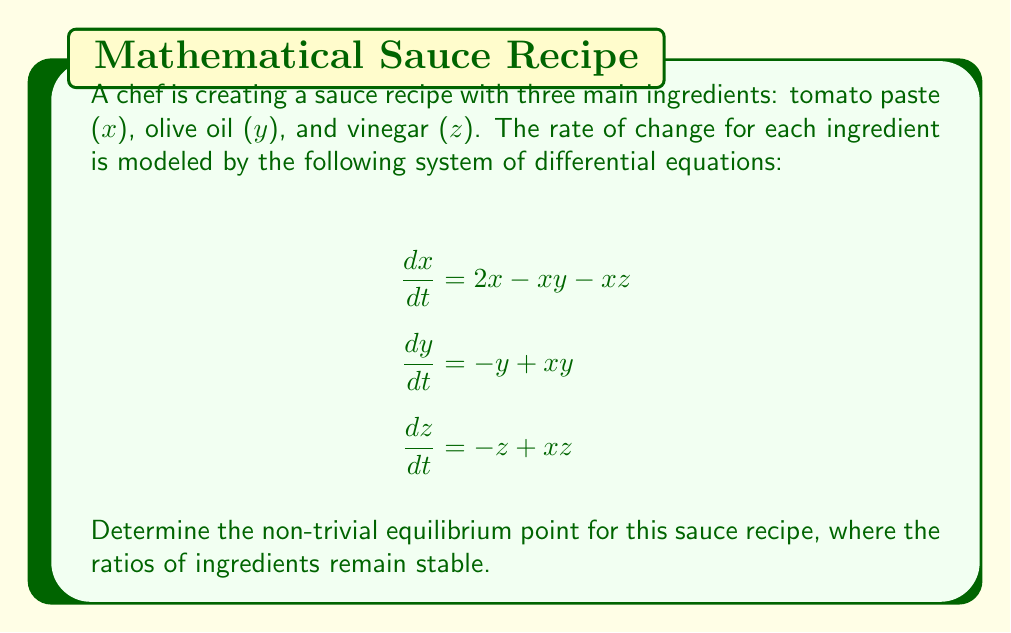Help me with this question. To find the equilibrium point, we need to set all derivatives to zero and solve the resulting system of equations:

1) Set all derivatives to zero:
   $$\begin{align}
   2x - xy - xz &= 0 \\
   -y + xy &= 0 \\
   -z + xz &= 0
   \end{align}$$

2) From the second equation:
   $-y + xy = 0$
   $y(x - 1) = 0$
   So, either $y = 0$ or $x = 1$. Since we're looking for the non-trivial solution, let $x = 1$.

3) From the third equation:
   $-z + xz = 0$
   $-z + 1z = 0$ (since $x = 1$)
   $0 = 0$
   This is always true, so $z$ can be any value.

4) Substitute $x = 1$ into the first equation:
   $2(1) - 1y - 1z = 0$
   $2 - y - z = 0$
   $y + z = 2$

5) Since we know $y + z = 2$, and both $y$ and $z$ are non-negative (as they represent ingredient quantities), we can conclude that $y = z = 1$.

Therefore, the non-trivial equilibrium point is (1, 1, 1).
Answer: (1, 1, 1) 